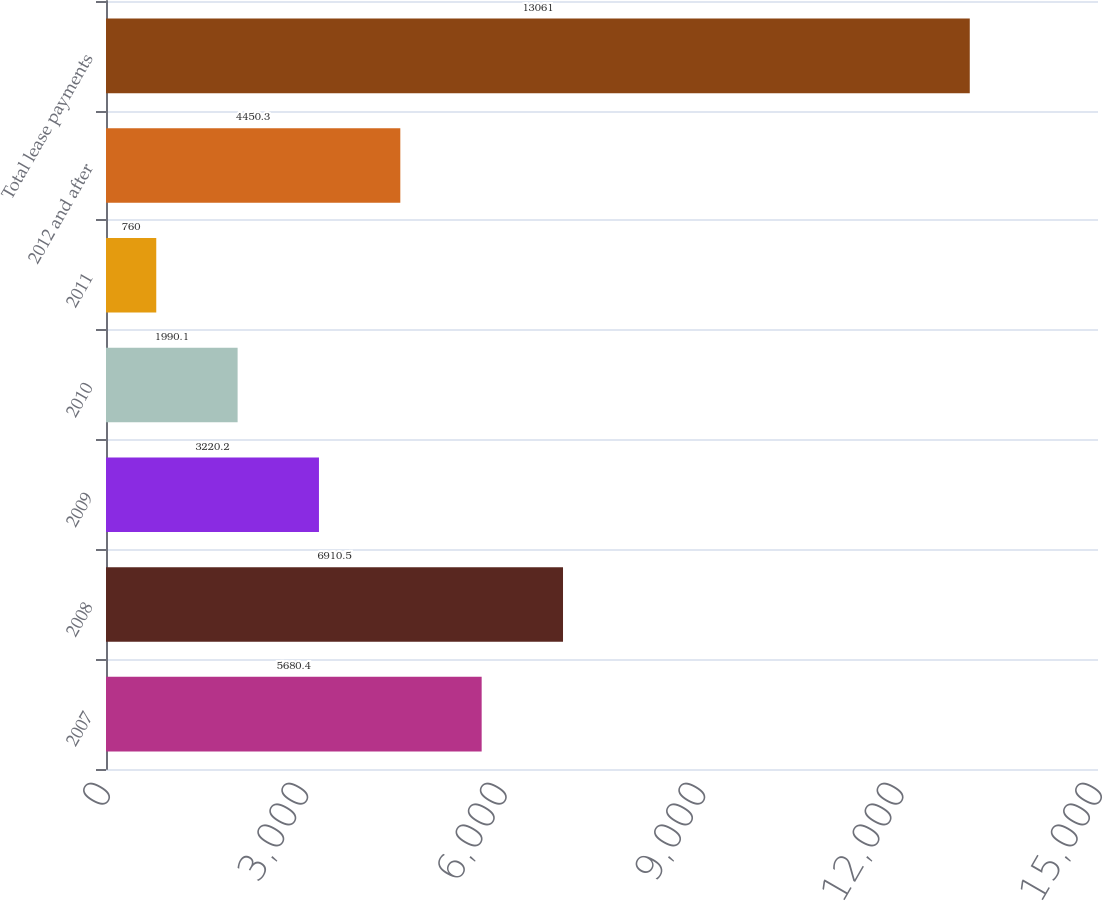Convert chart to OTSL. <chart><loc_0><loc_0><loc_500><loc_500><bar_chart><fcel>2007<fcel>2008<fcel>2009<fcel>2010<fcel>2011<fcel>2012 and after<fcel>Total lease payments<nl><fcel>5680.4<fcel>6910.5<fcel>3220.2<fcel>1990.1<fcel>760<fcel>4450.3<fcel>13061<nl></chart> 